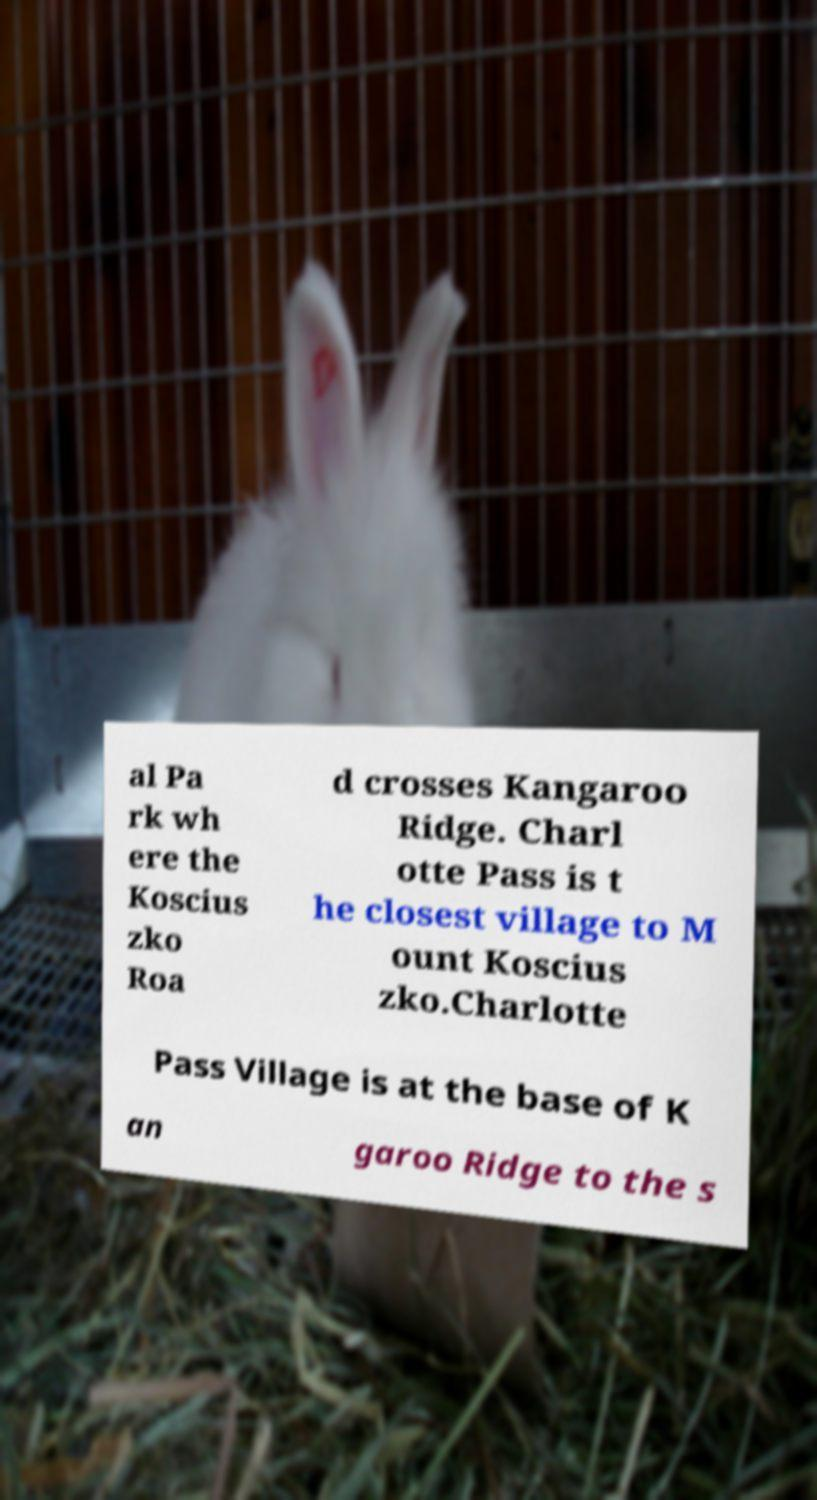There's text embedded in this image that I need extracted. Can you transcribe it verbatim? al Pa rk wh ere the Koscius zko Roa d crosses Kangaroo Ridge. Charl otte Pass is t he closest village to M ount Koscius zko.Charlotte Pass Village is at the base of K an garoo Ridge to the s 